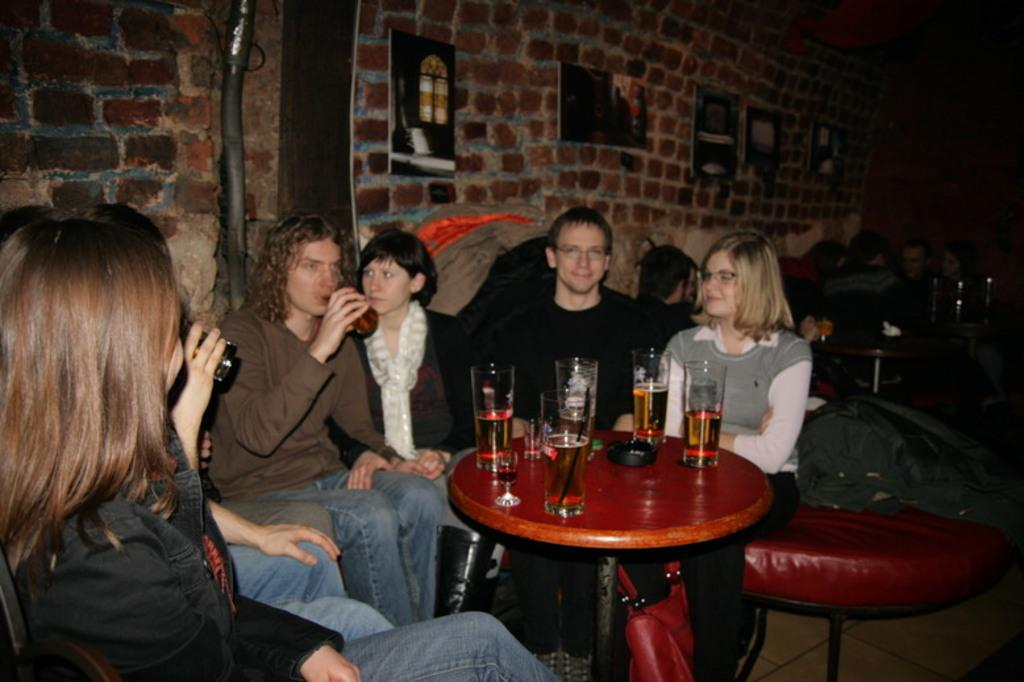What are the people in the image doing? There are persons sitting on chairs in the image. What is present on the table in the image? There is a table in the image, and many glasses are on the table. Can you describe the glasses visible behind the person? There are wine glasses visible behind the person. What else can be seen in the image besides the people and the table? There are posters in the image. How would you describe the overall lighting in the image? The background of the image is dark. What type of stitch is being used to sew the roof in the image? There is no mention of a roof or stitching in the image; it features persons sitting on chairs, a table, glasses, wine glasses, posters, and a dark background. 